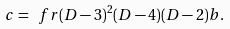<formula> <loc_0><loc_0><loc_500><loc_500>c = \ f r { ( D - 3 ) ^ { 2 } ( D - 4 ) } { ( D - 2 ) } b .</formula> 